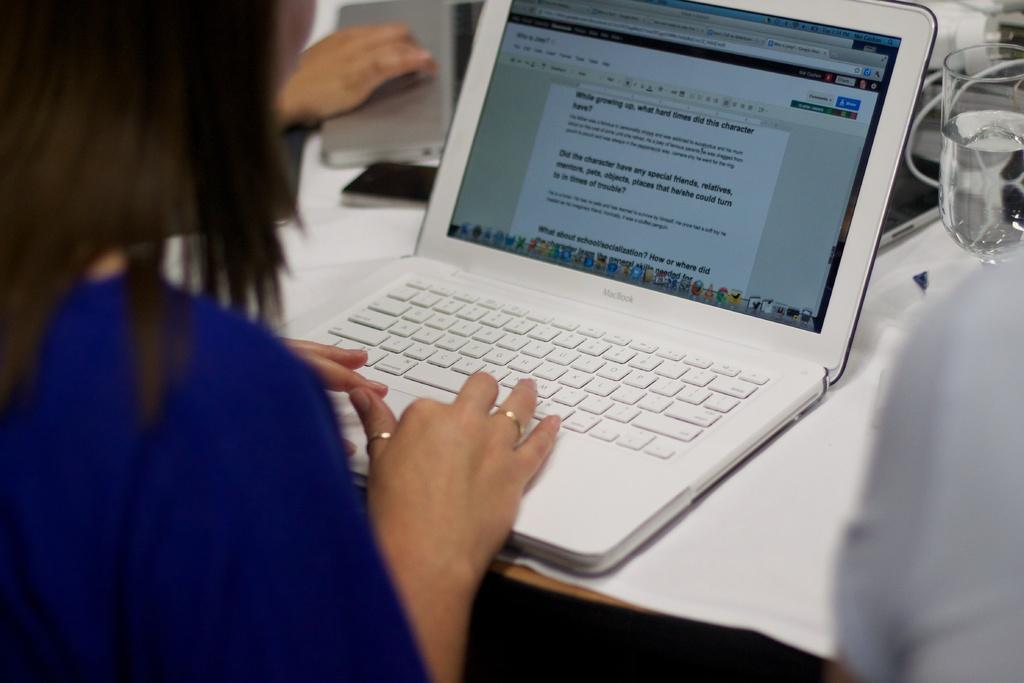Could you give a brief overview of what you see in this image? In this image we can see a woman is sitting, in front there is a laptop on the table, beside there is a glass and some objects on it. 